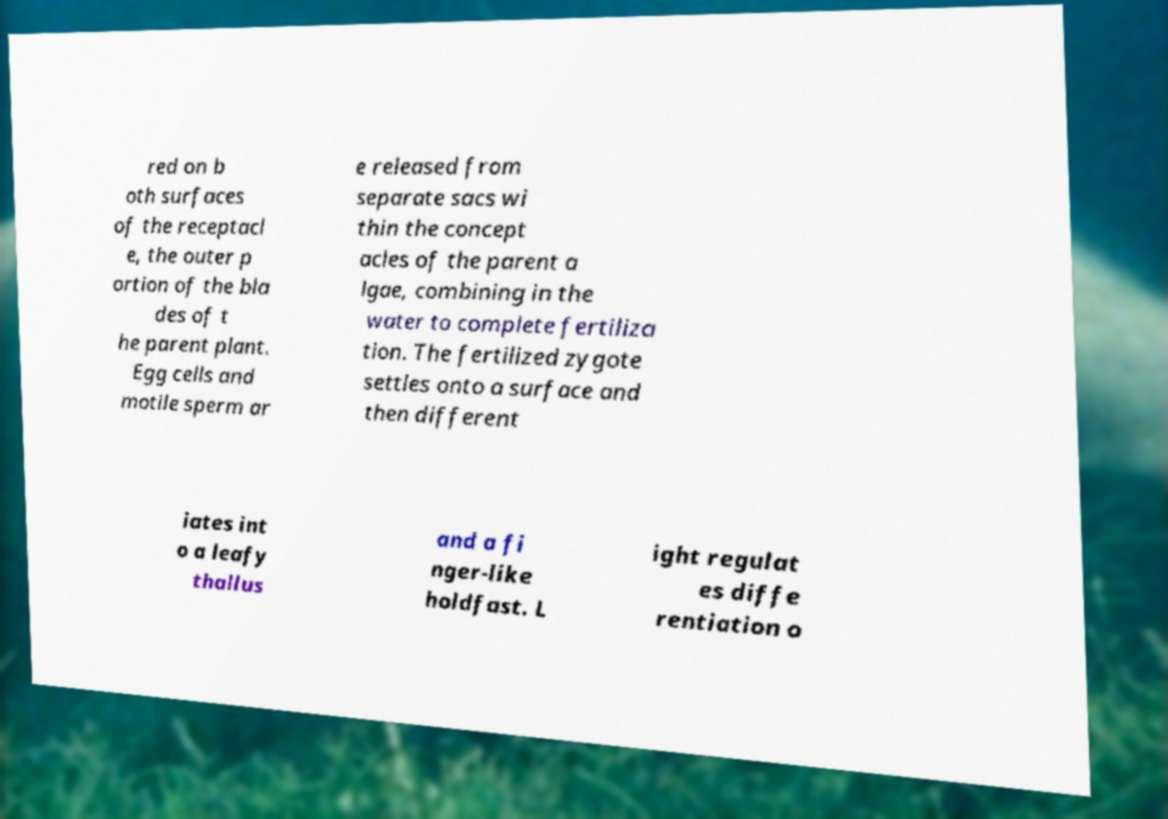For documentation purposes, I need the text within this image transcribed. Could you provide that? red on b oth surfaces of the receptacl e, the outer p ortion of the bla des of t he parent plant. Egg cells and motile sperm ar e released from separate sacs wi thin the concept acles of the parent a lgae, combining in the water to complete fertiliza tion. The fertilized zygote settles onto a surface and then different iates int o a leafy thallus and a fi nger-like holdfast. L ight regulat es diffe rentiation o 